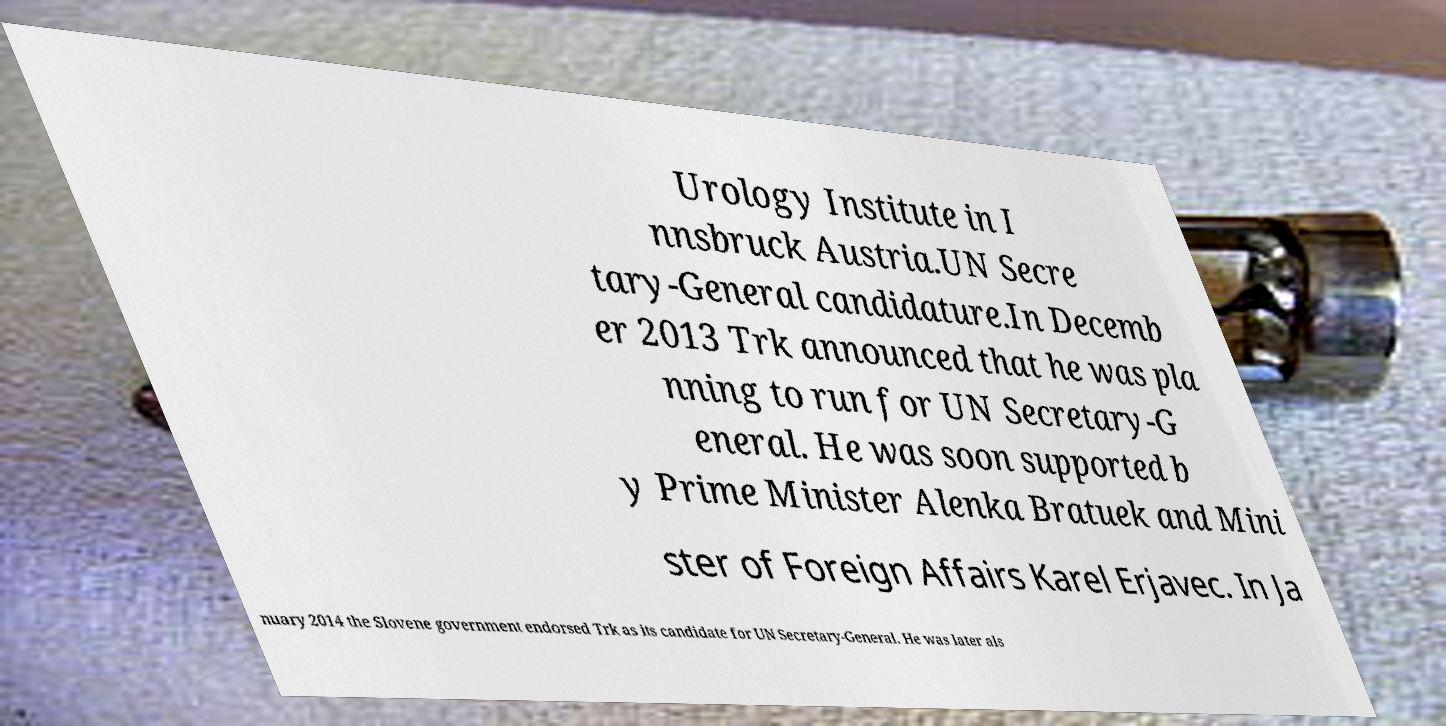Could you extract and type out the text from this image? Urology Institute in I nnsbruck Austria.UN Secre tary-General candidature.In Decemb er 2013 Trk announced that he was pla nning to run for UN Secretary-G eneral. He was soon supported b y Prime Minister Alenka Bratuek and Mini ster of Foreign Affairs Karel Erjavec. In Ja nuary 2014 the Slovene government endorsed Trk as its candidate for UN Secretary-General. He was later als 